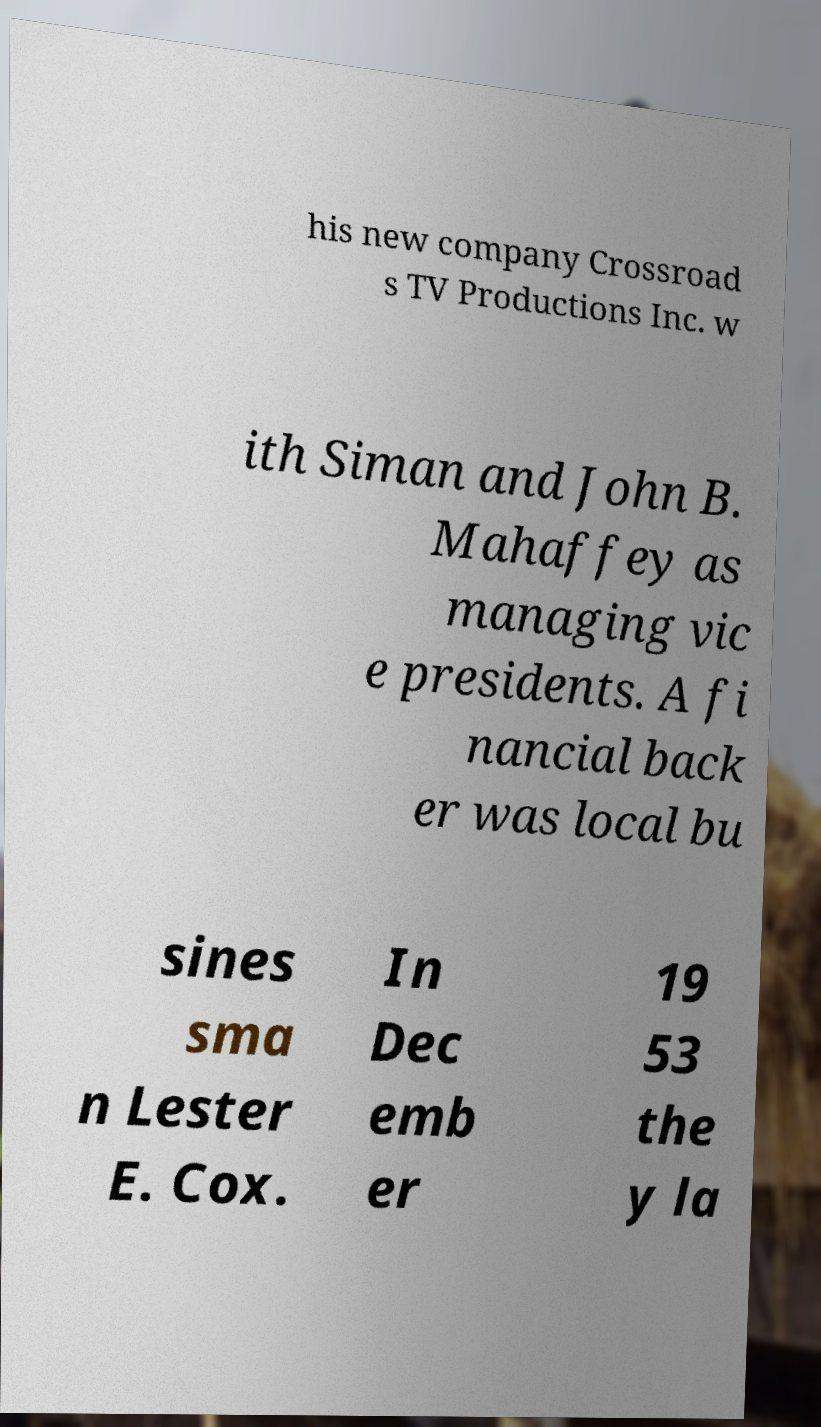Could you extract and type out the text from this image? his new company Crossroad s TV Productions Inc. w ith Siman and John B. Mahaffey as managing vic e presidents. A fi nancial back er was local bu sines sma n Lester E. Cox. In Dec emb er 19 53 the y la 